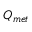Convert formula to latex. <formula><loc_0><loc_0><loc_500><loc_500>Q _ { m e t }</formula> 